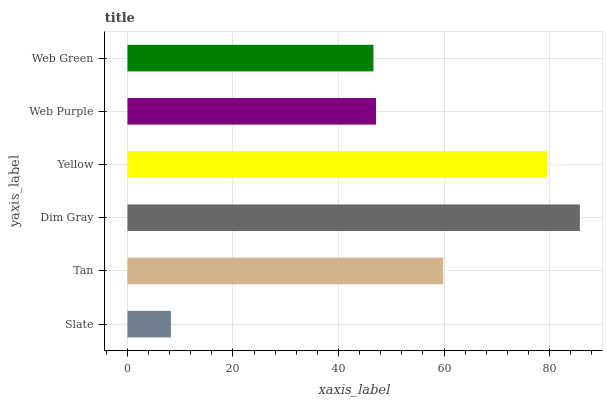Is Slate the minimum?
Answer yes or no. Yes. Is Dim Gray the maximum?
Answer yes or no. Yes. Is Tan the minimum?
Answer yes or no. No. Is Tan the maximum?
Answer yes or no. No. Is Tan greater than Slate?
Answer yes or no. Yes. Is Slate less than Tan?
Answer yes or no. Yes. Is Slate greater than Tan?
Answer yes or no. No. Is Tan less than Slate?
Answer yes or no. No. Is Tan the high median?
Answer yes or no. Yes. Is Web Purple the low median?
Answer yes or no. Yes. Is Yellow the high median?
Answer yes or no. No. Is Tan the low median?
Answer yes or no. No. 